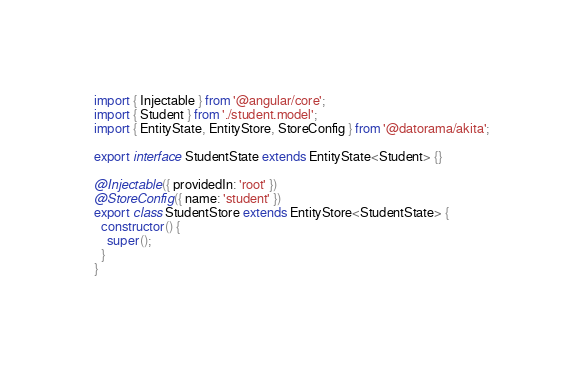<code> <loc_0><loc_0><loc_500><loc_500><_TypeScript_>import { Injectable } from '@angular/core';
import { Student } from './student.model';
import { EntityState, EntityStore, StoreConfig } from '@datorama/akita';

export interface StudentState extends EntityState<Student> {}

@Injectable({ providedIn: 'root' })
@StoreConfig({ name: 'student' })
export class StudentStore extends EntityStore<StudentState> {
  constructor() {
    super();
  }
}
</code> 